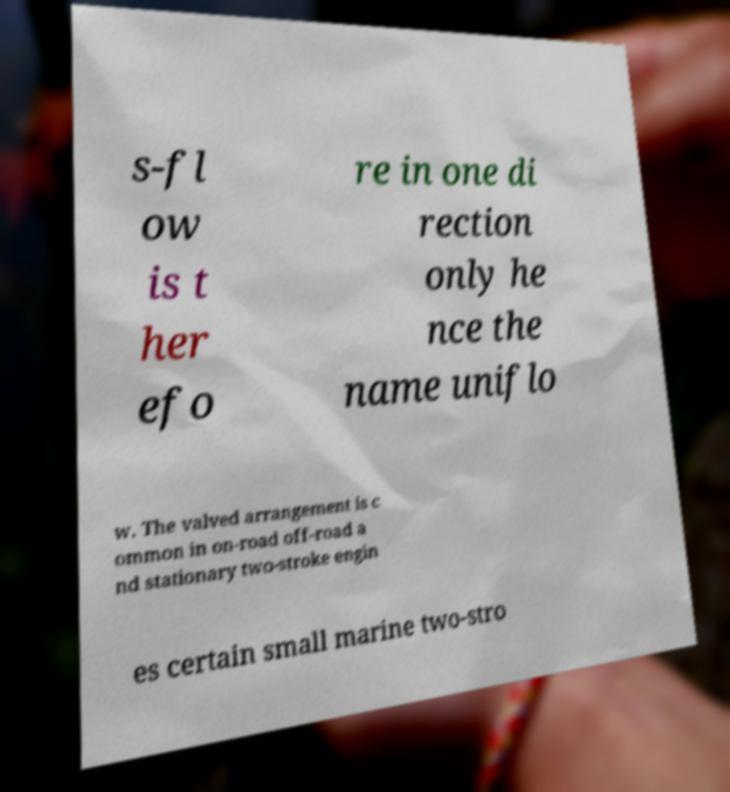Could you extract and type out the text from this image? s-fl ow is t her efo re in one di rection only he nce the name uniflo w. The valved arrangement is c ommon in on-road off-road a nd stationary two-stroke engin es certain small marine two-stro 